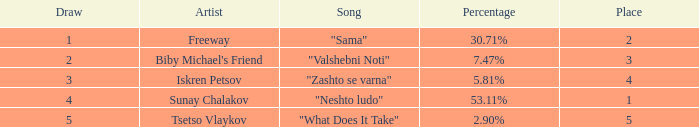What is the highest draw when the place is less than 3 and the percentage is 30.71%? 1.0. 